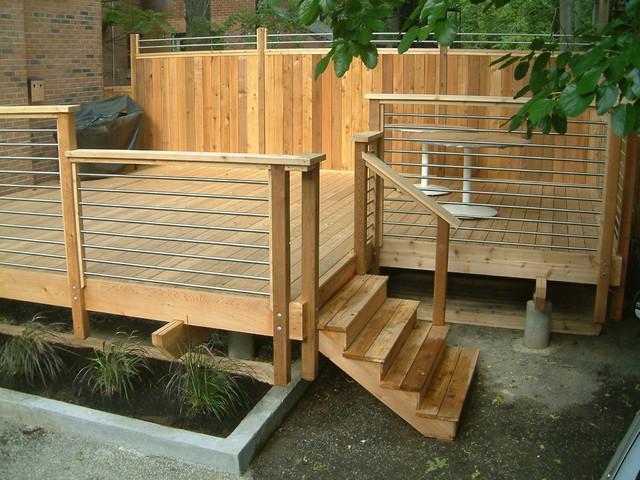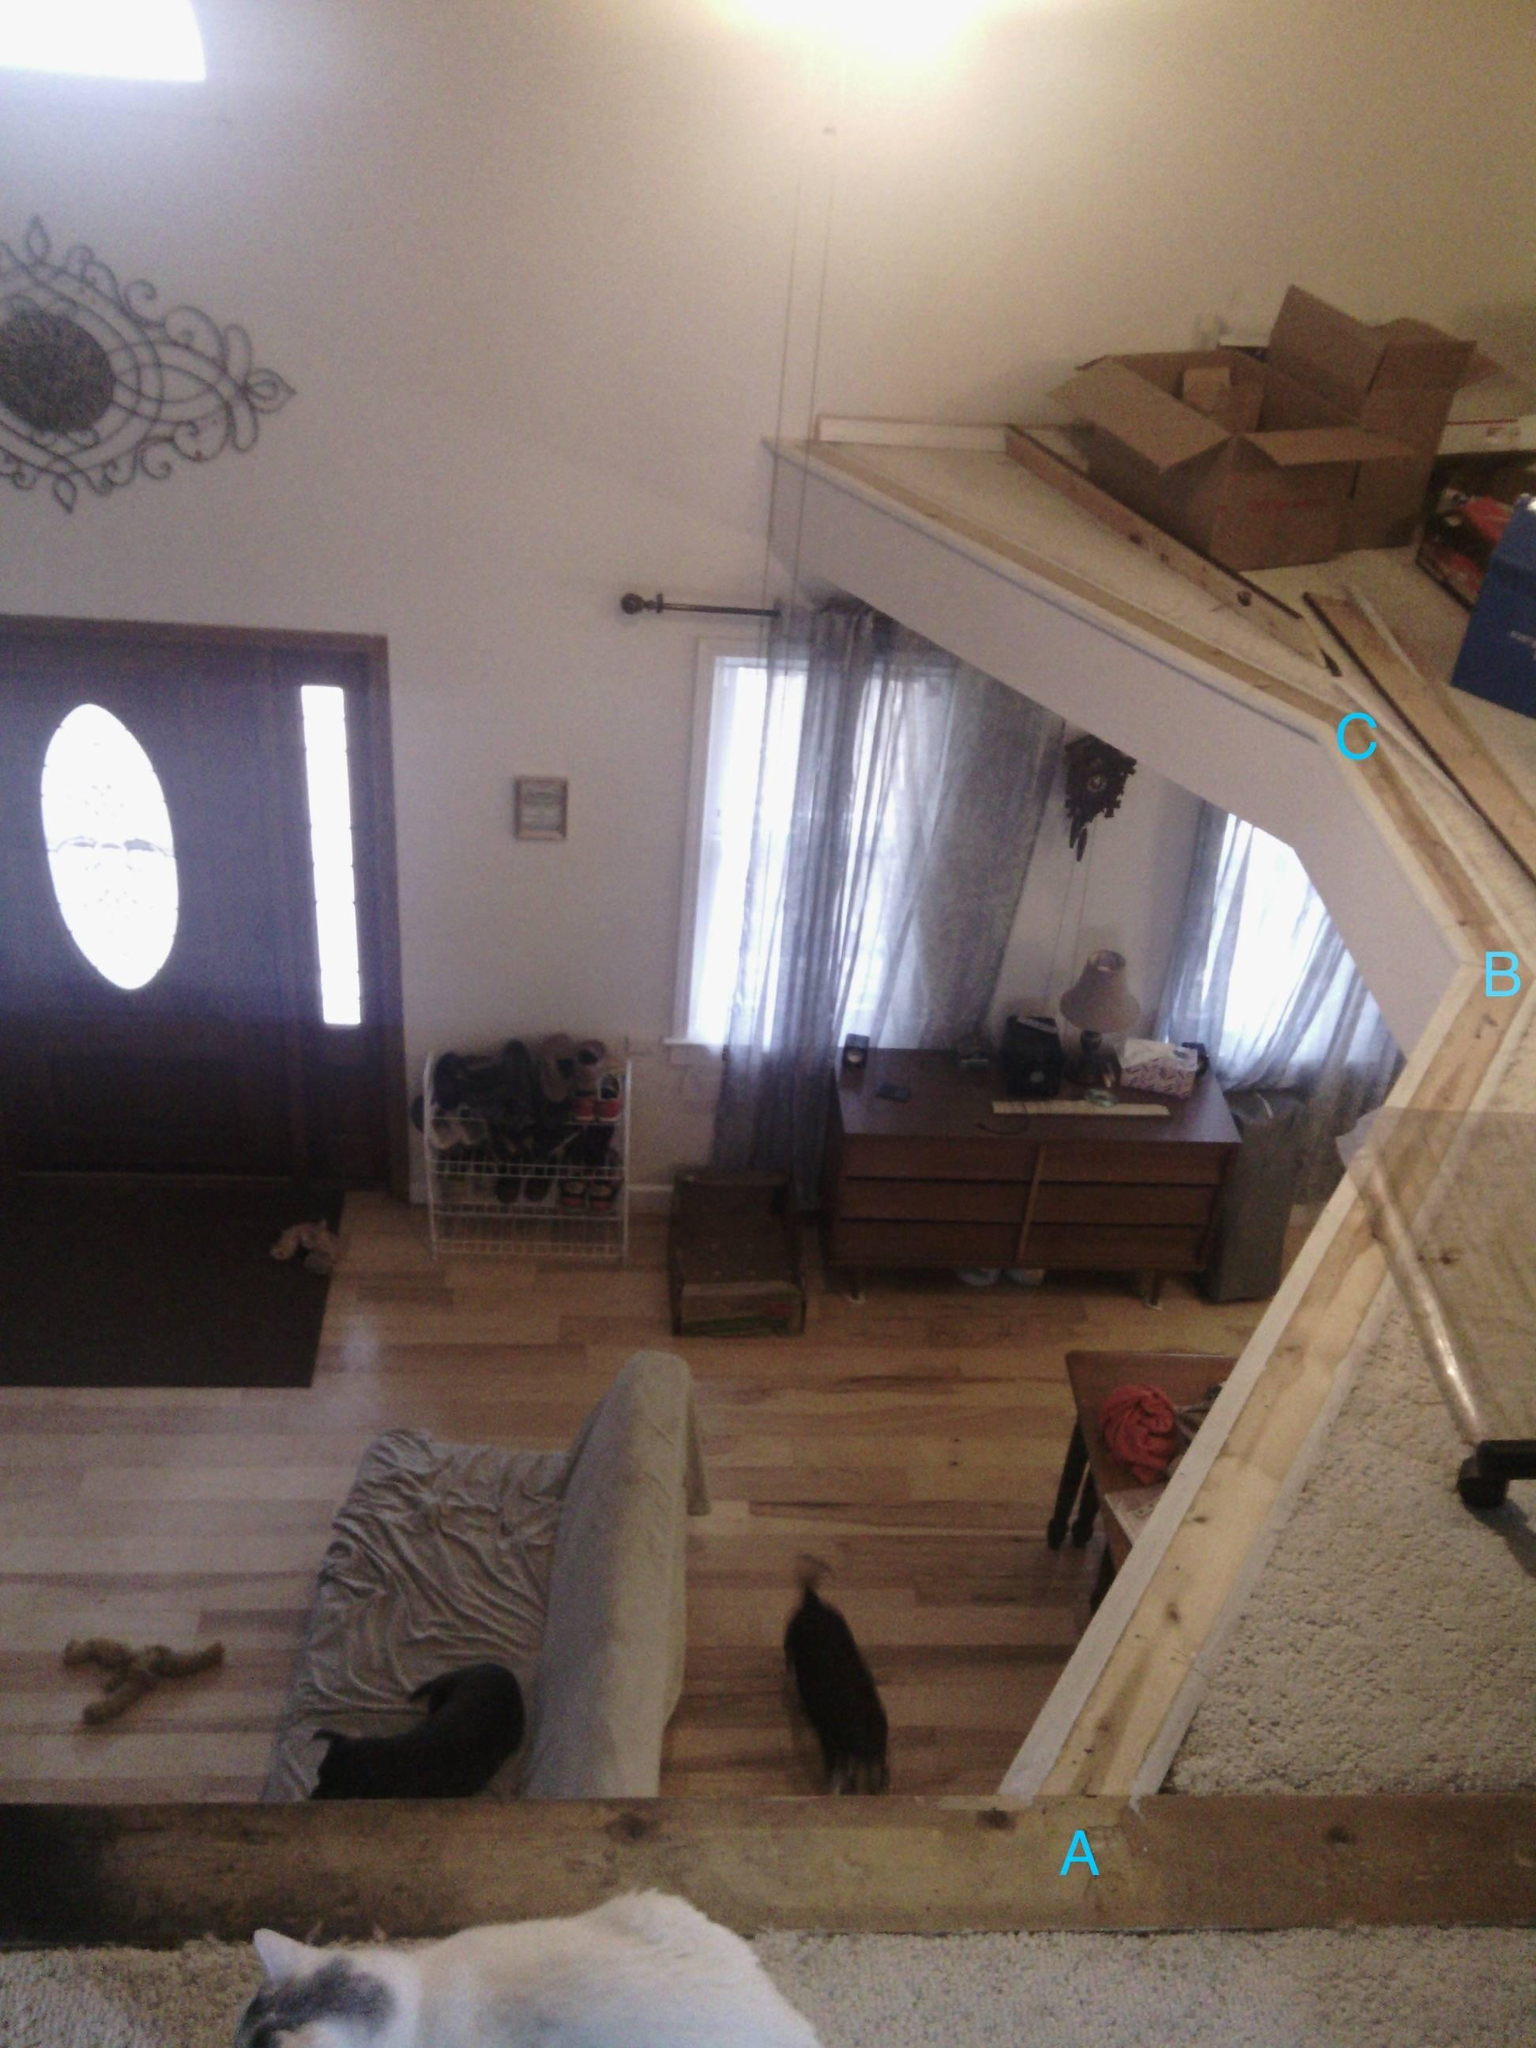The first image is the image on the left, the second image is the image on the right. Given the left and right images, does the statement "The left and right image contains the same number of staircases." hold true? Answer yes or no. No. 